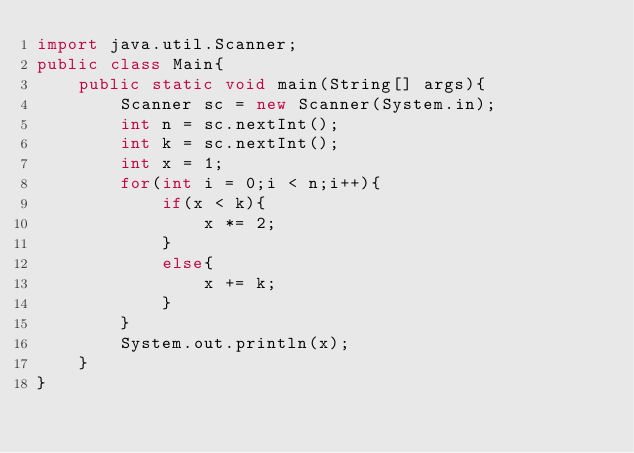Convert code to text. <code><loc_0><loc_0><loc_500><loc_500><_Java_>import java.util.Scanner;
public class Main{
    public static void main(String[] args){
        Scanner sc = new Scanner(System.in);
        int n = sc.nextInt();
        int k = sc.nextInt();
        int x = 1;
        for(int i = 0;i < n;i++){
            if(x < k){
                x *= 2;
            }
            else{
                x += k;
            }
        }
        System.out.println(x);
    }
}
</code> 